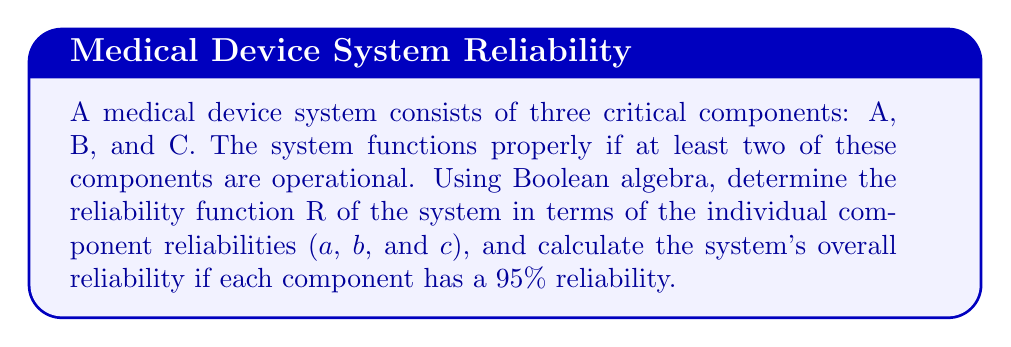Solve this math problem. Step 1: Define the Boolean function for the system reliability.
Let R be the system reliability function, where:
R = 1 if the system is operational
R = 0 if the system fails

Step 2: Express the conditions for system operation using Boolean algebra.
The system operates if:
(A AND B) OR (A AND C) OR (B AND C)

Step 3: Translate this into a Boolean expression:
$$R = AB + AC + BC$$

Step 4: Expand the expression using the distributive property:
$$R = AB + AC + BC$$
$$R = AB + (A + B)C$$

Step 5: Apply the given component reliabilities:
a = b = c = 0.95

Step 6: Substitute these values into the reliability function:
$$R = (0.95)(0.95) + (0.95 + 0.95)(0.95)$$

Step 7: Simplify:
$$R = 0.9025 + (1.9)(0.95)$$
$$R = 0.9025 + 1.805$$
$$R = 2.7075$$

Step 8: Interpret the result:
Since reliability is a probability, it cannot exceed 1. The value 2.7075 represents the sum of probabilities of different operational scenarios. To get the actual reliability, we need to subtract the overlapping probabilities:

$$R = 1 - (1-a)(1-b)(1-c)$$
$$R = 1 - (0.05)(0.05)(0.05)$$
$$R = 1 - 0.000125$$
$$R = 0.999875$$

Therefore, the overall system reliability is 0.999875 or 99.9875%.
Answer: $R = AB + AC + BC = 0.999875$ 